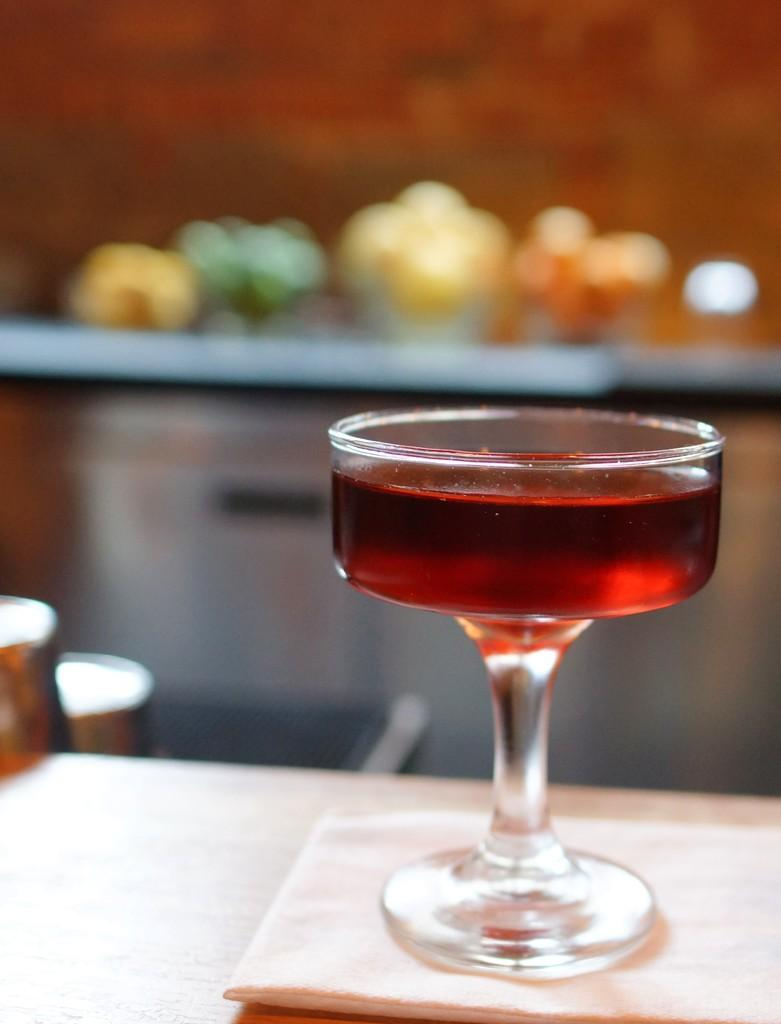What is inside the glass that is visible in the image? There is a glass containing liquid in the image. Where is the glass located in the image? The glass is placed on a surface. What can be seen in the background of the image? There are objects in the background of the image. Where are the objects located in the image? The objects are placed on a table. What theory is being discussed by the objects on the table in the image? There is no indication in the image that a theory is being discussed, as the objects are not people or capable of discussing theories. 